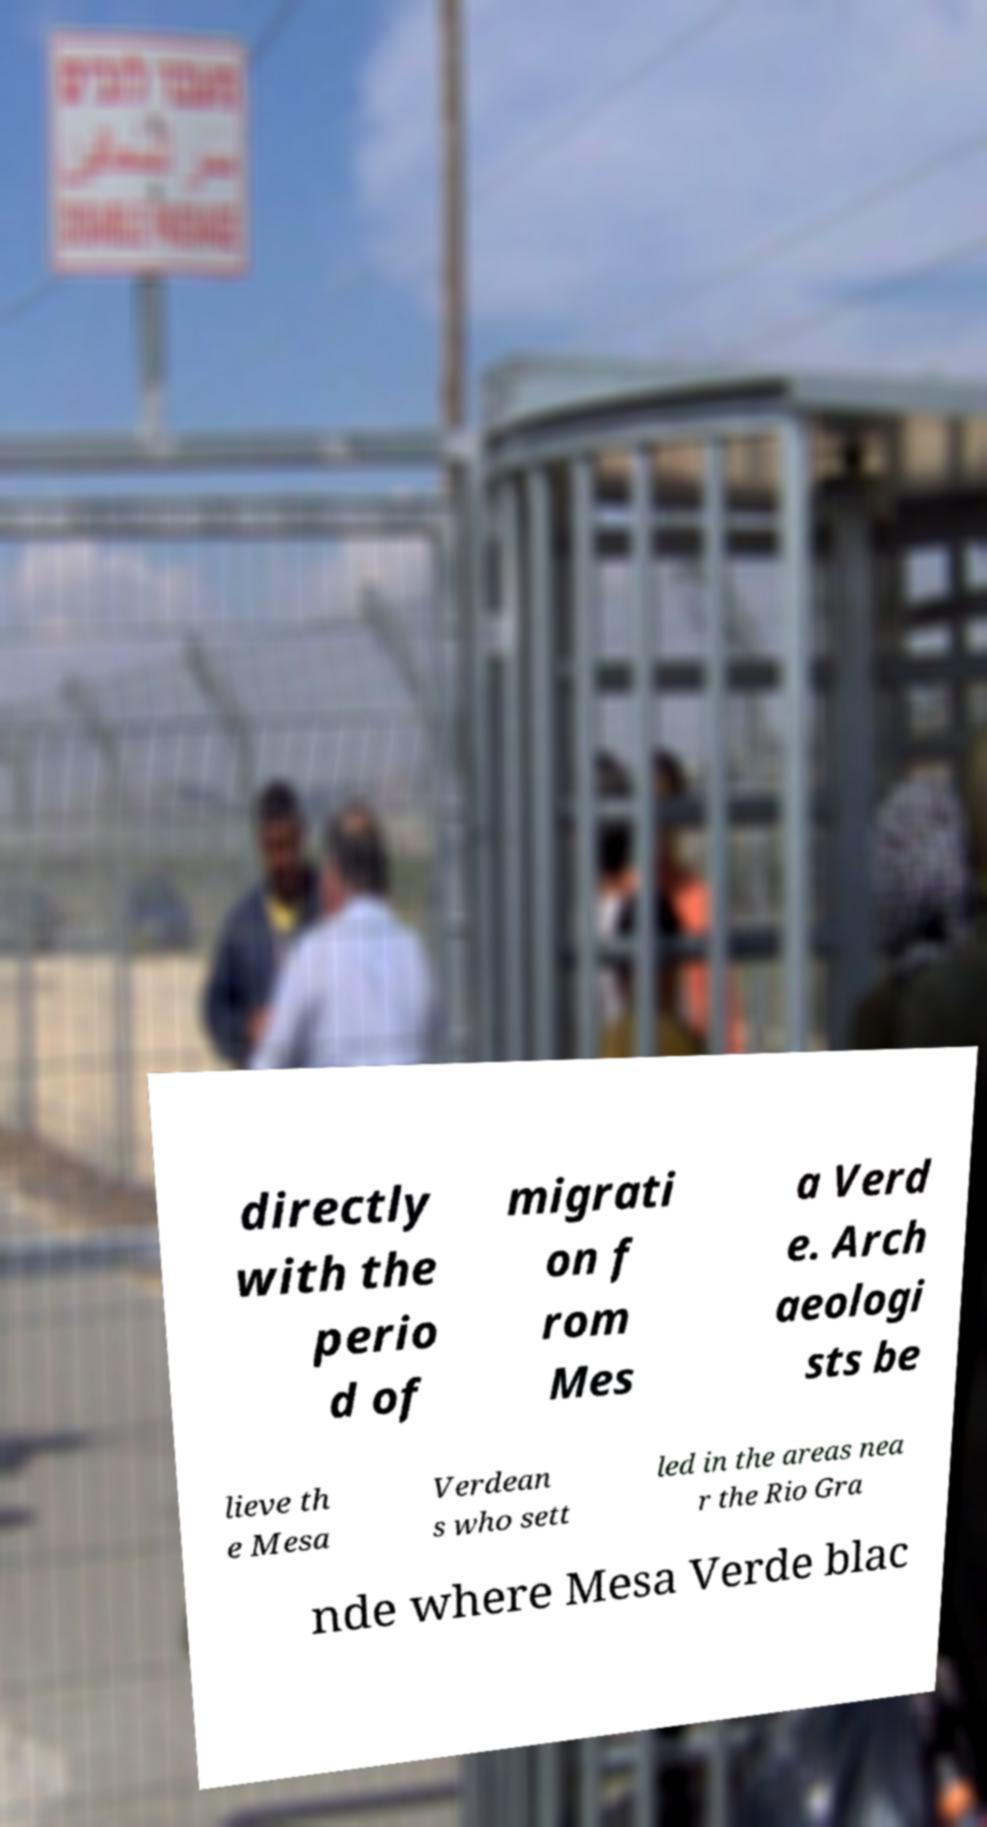Could you assist in decoding the text presented in this image and type it out clearly? directly with the perio d of migrati on f rom Mes a Verd e. Arch aeologi sts be lieve th e Mesa Verdean s who sett led in the areas nea r the Rio Gra nde where Mesa Verde blac 